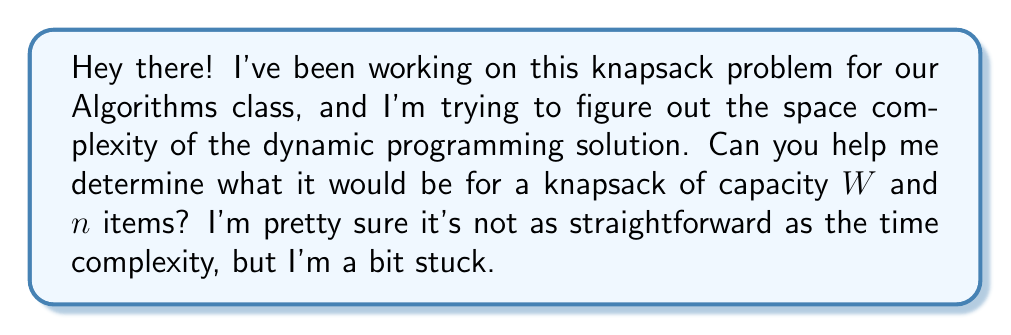Show me your answer to this math problem. Alright, let's think this through together! The dynamic programming solution for the knapsack problem typically uses a 2D array to store the intermediate results. Here's how we can break it down:

1) We create a 2D array $dp[i][w]$, where:
   - $i$ ranges from $0$ to $n$ (number of items)
   - $w$ ranges from $0$ to $W$ (capacity of the knapsack)

2) The dimensions of this array are $(n+1) \times (W+1)$

3) Each cell in this array stores a single integer value, representing the maximum value that can be achieved with the first $i$ items and a knapsack of capacity $w$.

4) In terms of space complexity, we need to consider the size of this array:
   $$\text{Space} = (n+1) \times (W+1) \times \text{size of integer}$$

5) The size of an integer is typically constant (let's say 4 bytes), so we can simplify this to:
   $$\text{Space} = O(nW)$$

6) It's important to note that this space complexity is pseudo-polynomial, as it depends on the numeric value of $W$, not just the number of items.

7) There's also a more space-efficient version that uses only a 1D array of size $W+1$, which would give us a space complexity of $O(W)$. However, the standard implementation uses the 2D array.

So, the space complexity of the standard dynamic programming solution for the knapsack problem is $O(nW)$.
Answer: The space complexity of the standard dynamic programming solution for the knapsack problem is $O(nW)$, where $n$ is the number of items and $W$ is the capacity of the knapsack. 